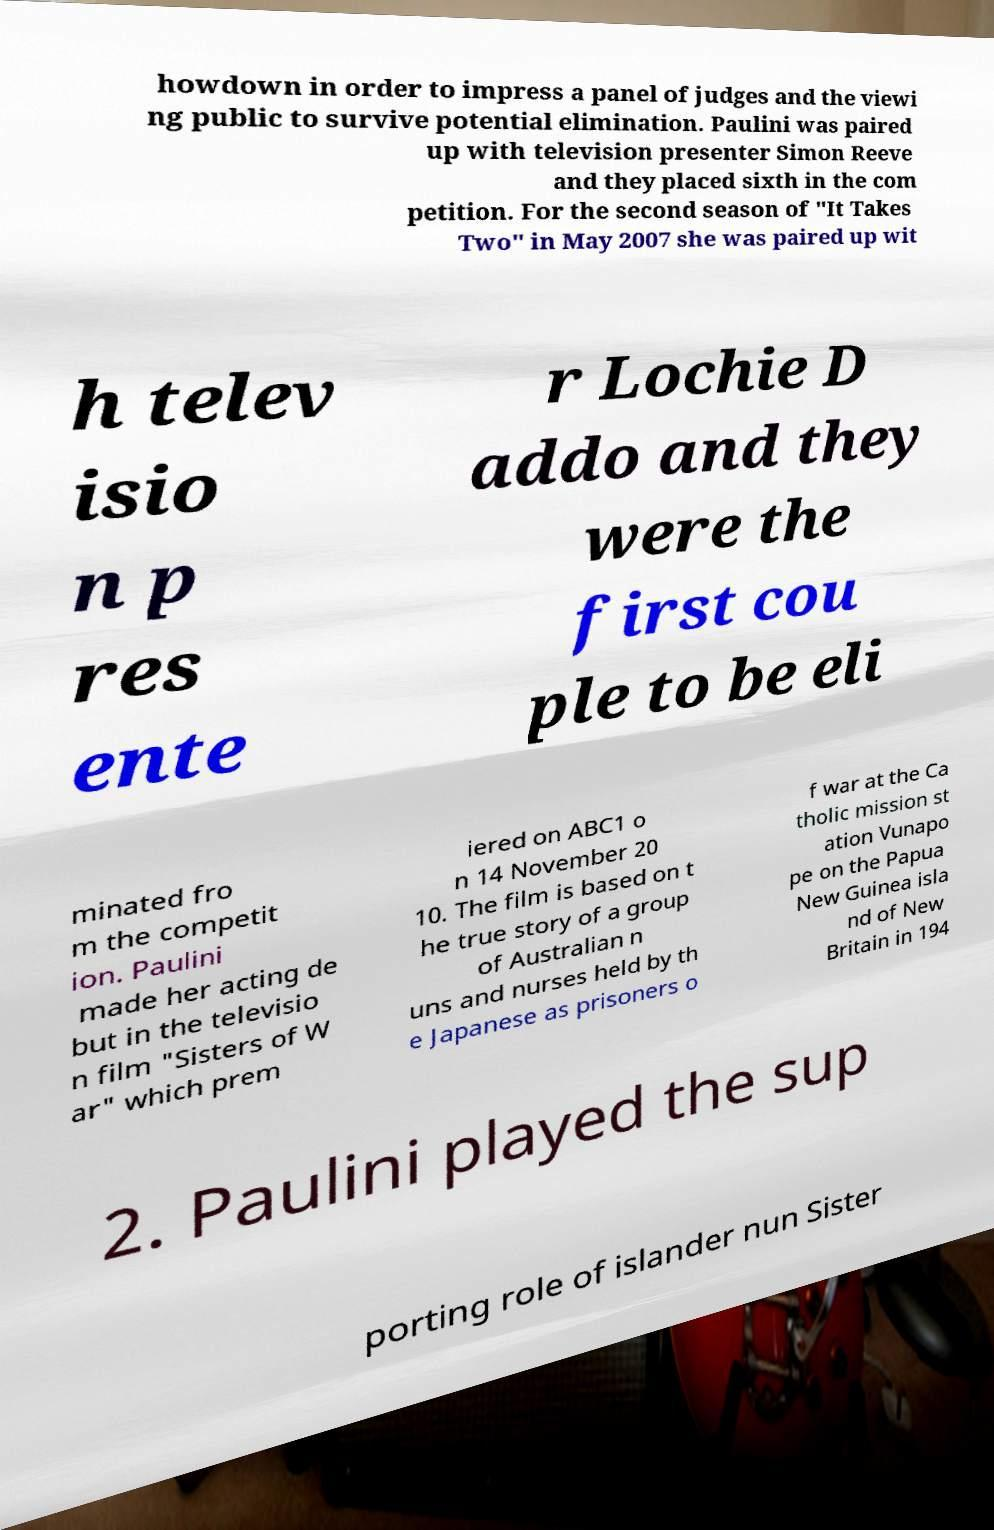Could you assist in decoding the text presented in this image and type it out clearly? howdown in order to impress a panel of judges and the viewi ng public to survive potential elimination. Paulini was paired up with television presenter Simon Reeve and they placed sixth in the com petition. For the second season of "It Takes Two" in May 2007 she was paired up wit h telev isio n p res ente r Lochie D addo and they were the first cou ple to be eli minated fro m the competit ion. Paulini made her acting de but in the televisio n film "Sisters of W ar" which prem iered on ABC1 o n 14 November 20 10. The film is based on t he true story of a group of Australian n uns and nurses held by th e Japanese as prisoners o f war at the Ca tholic mission st ation Vunapo pe on the Papua New Guinea isla nd of New Britain in 194 2. Paulini played the sup porting role of islander nun Sister 